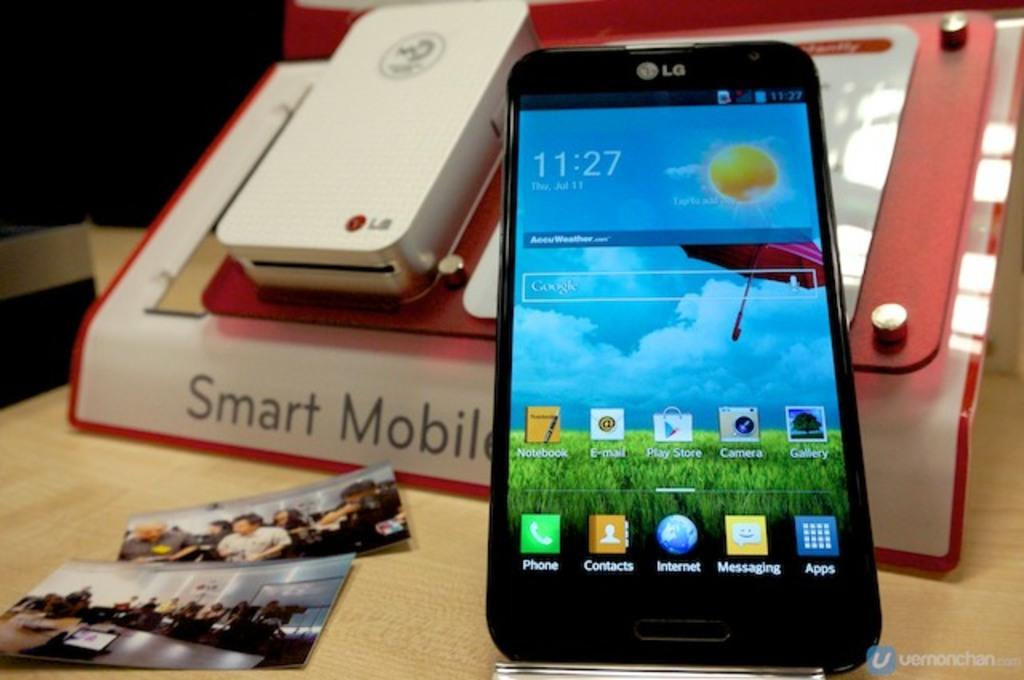<image>
Provide a brief description of the given image. A book is displayed behind a phone that says "smart mobile" 